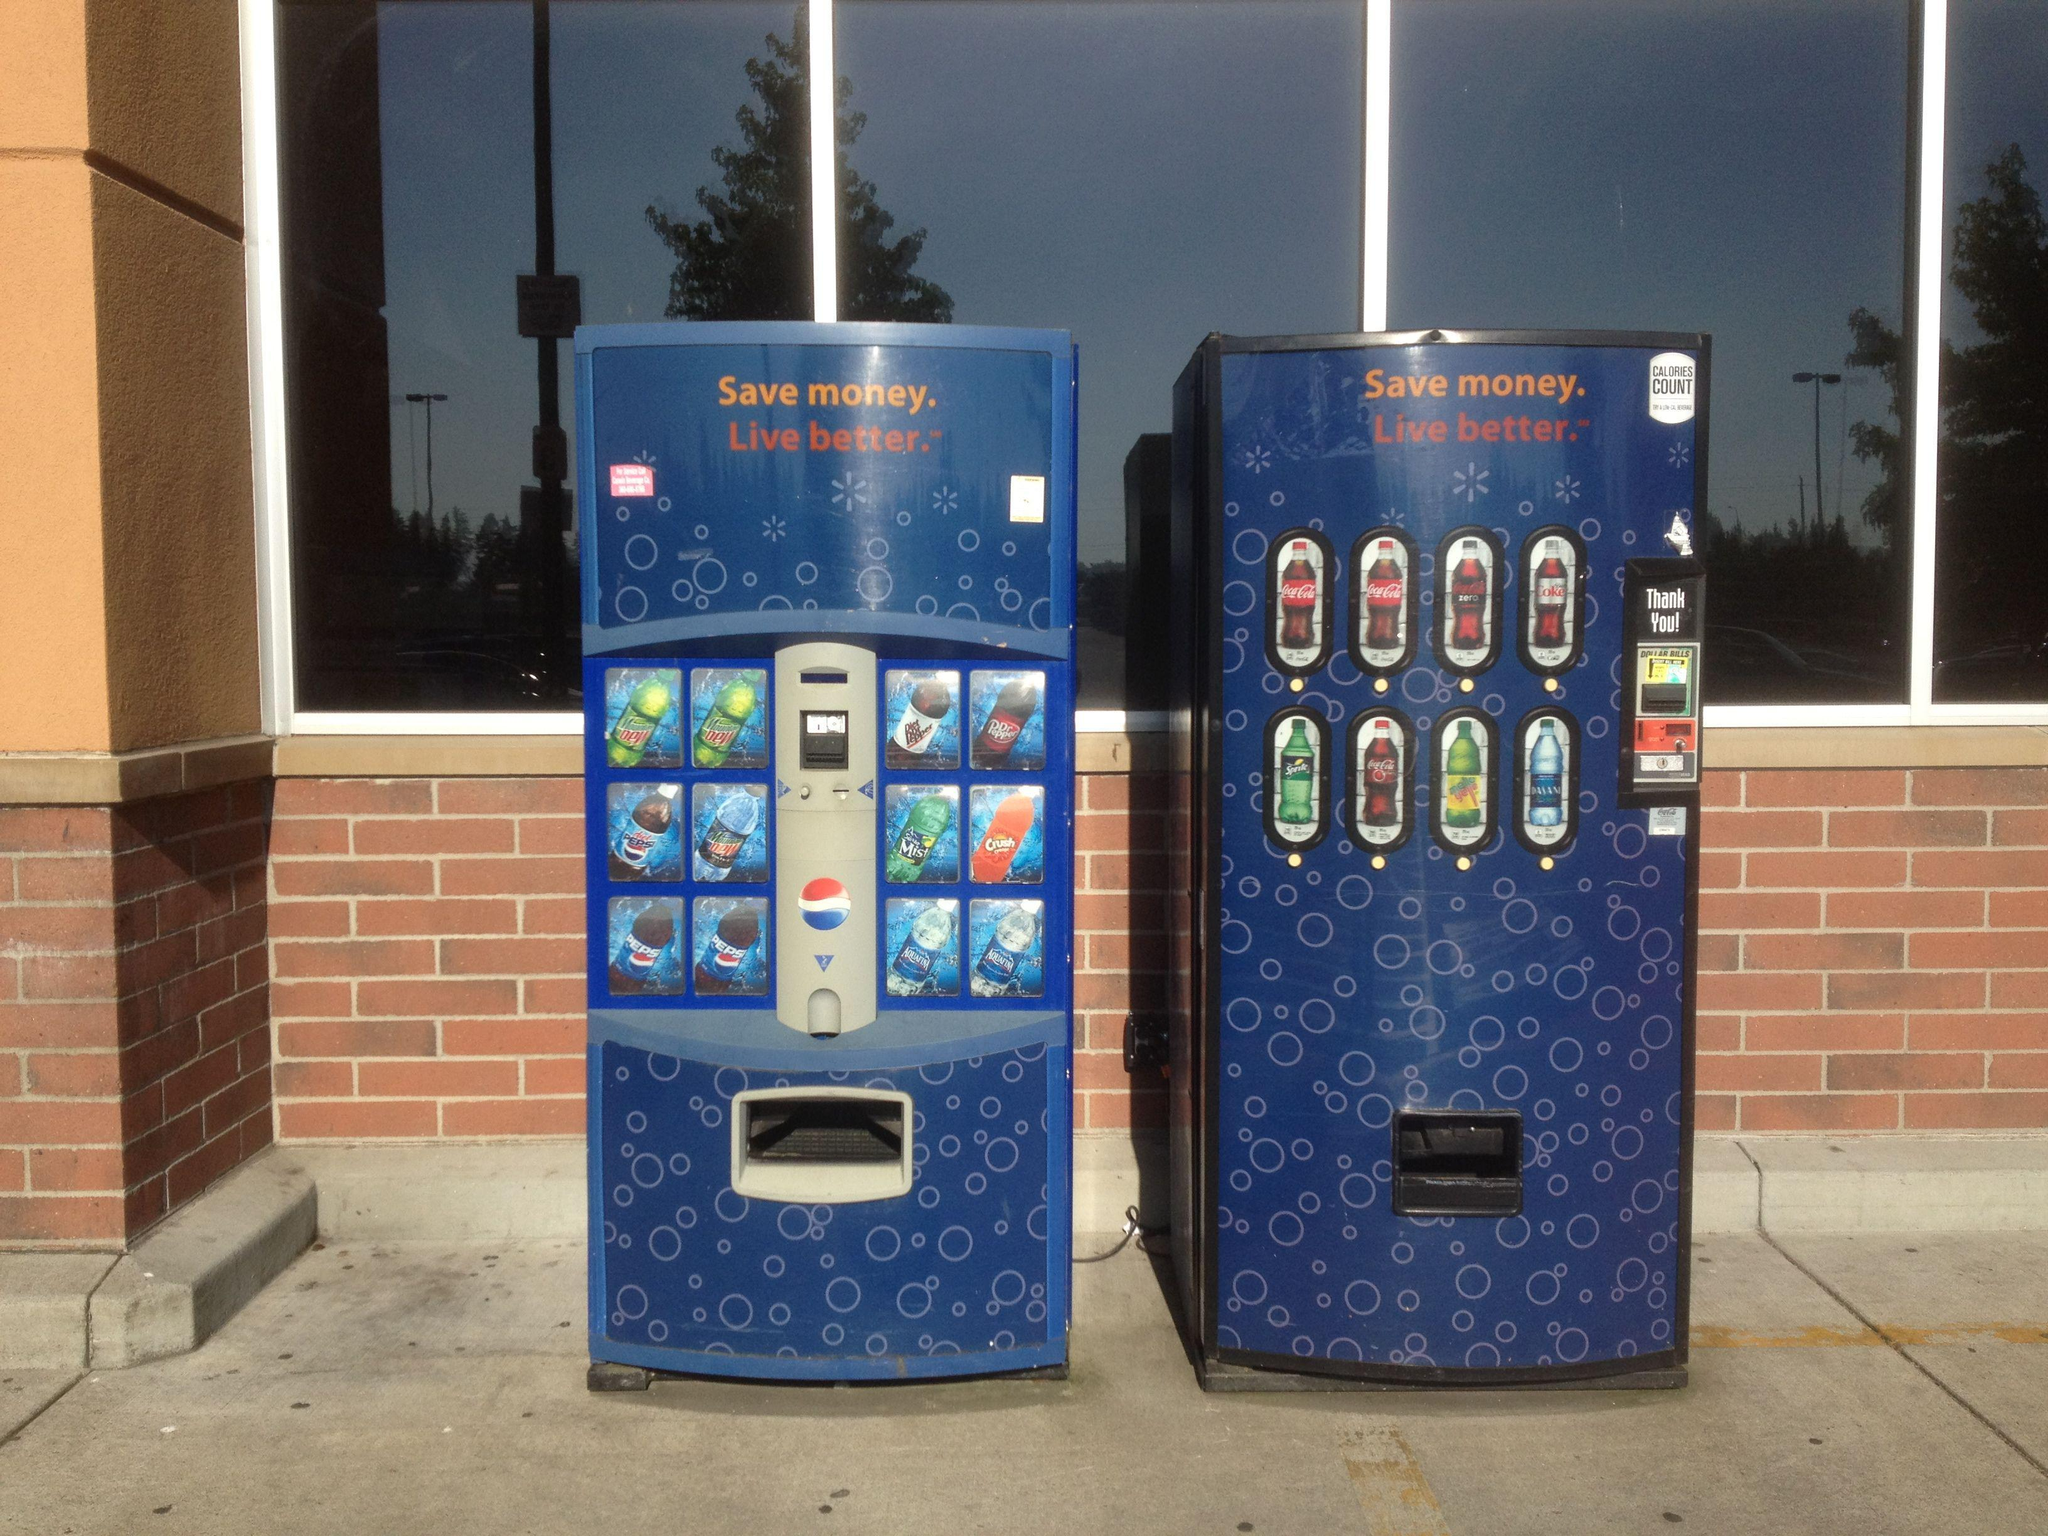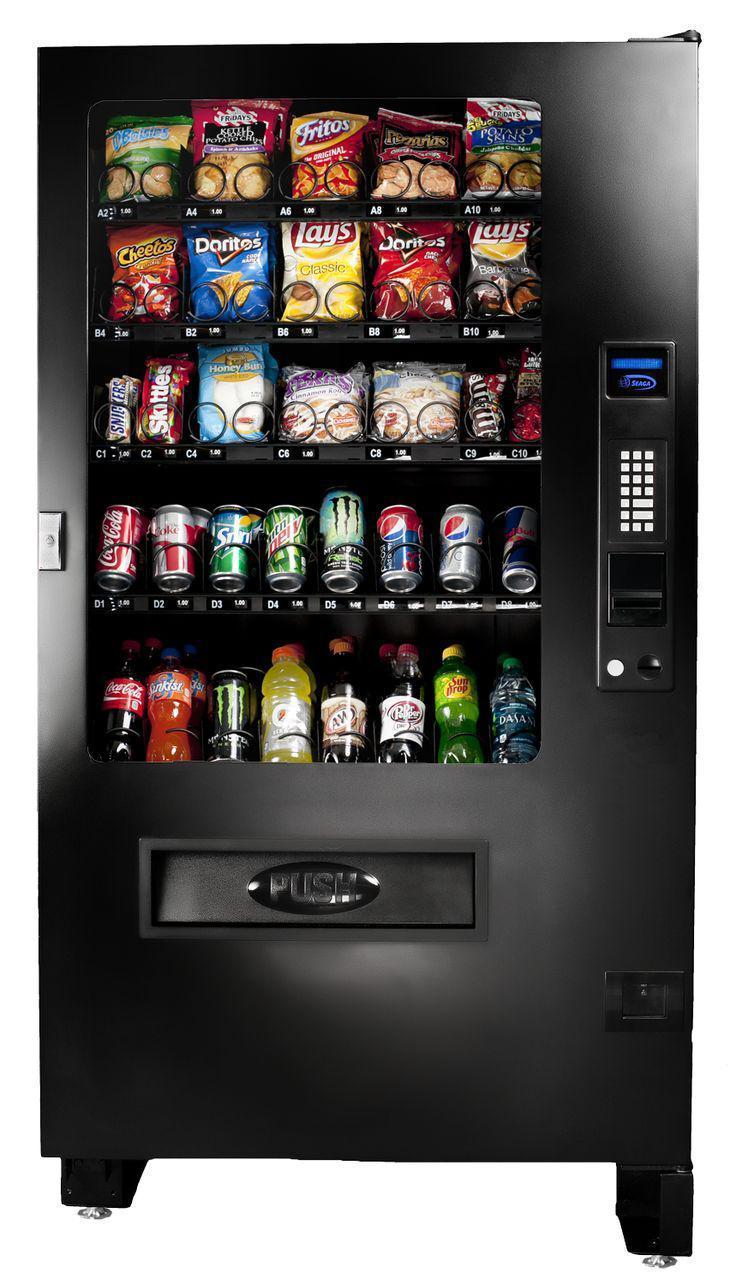The first image is the image on the left, the second image is the image on the right. Considering the images on both sides, is "There's the same number of vending machines in each image." valid? Answer yes or no. No. The first image is the image on the left, the second image is the image on the right. Examine the images to the left and right. Is the description "The left image contains no more than two vending machines." accurate? Answer yes or no. Yes. 